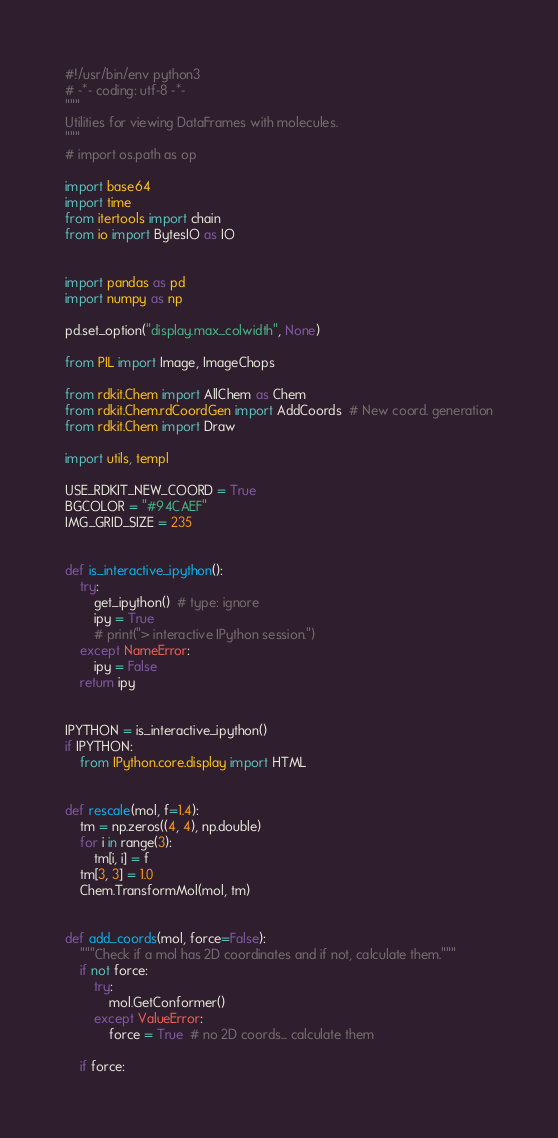Convert code to text. <code><loc_0><loc_0><loc_500><loc_500><_Python_>#!/usr/bin/env python3
# -*- coding: utf-8 -*-
"""
Utilities for viewing DataFrames with molecules.
"""
# import os.path as op

import base64
import time
from itertools import chain
from io import BytesIO as IO


import pandas as pd
import numpy as np

pd.set_option("display.max_colwidth", None)

from PIL import Image, ImageChops

from rdkit.Chem import AllChem as Chem
from rdkit.Chem.rdCoordGen import AddCoords  # New coord. generation
from rdkit.Chem import Draw

import utils, templ

USE_RDKIT_NEW_COORD = True
BGCOLOR = "#94CAEF"
IMG_GRID_SIZE = 235


def is_interactive_ipython():
    try:
        get_ipython()  # type: ignore
        ipy = True
        # print("> interactive IPython session.")
    except NameError:
        ipy = False
    return ipy


IPYTHON = is_interactive_ipython()
if IPYTHON:
    from IPython.core.display import HTML


def rescale(mol, f=1.4):
    tm = np.zeros((4, 4), np.double)
    for i in range(3):
        tm[i, i] = f
    tm[3, 3] = 1.0
    Chem.TransformMol(mol, tm)


def add_coords(mol, force=False):
    """Check if a mol has 2D coordinates and if not, calculate them."""
    if not force:
        try:
            mol.GetConformer()
        except ValueError:
            force = True  # no 2D coords... calculate them

    if force:</code> 